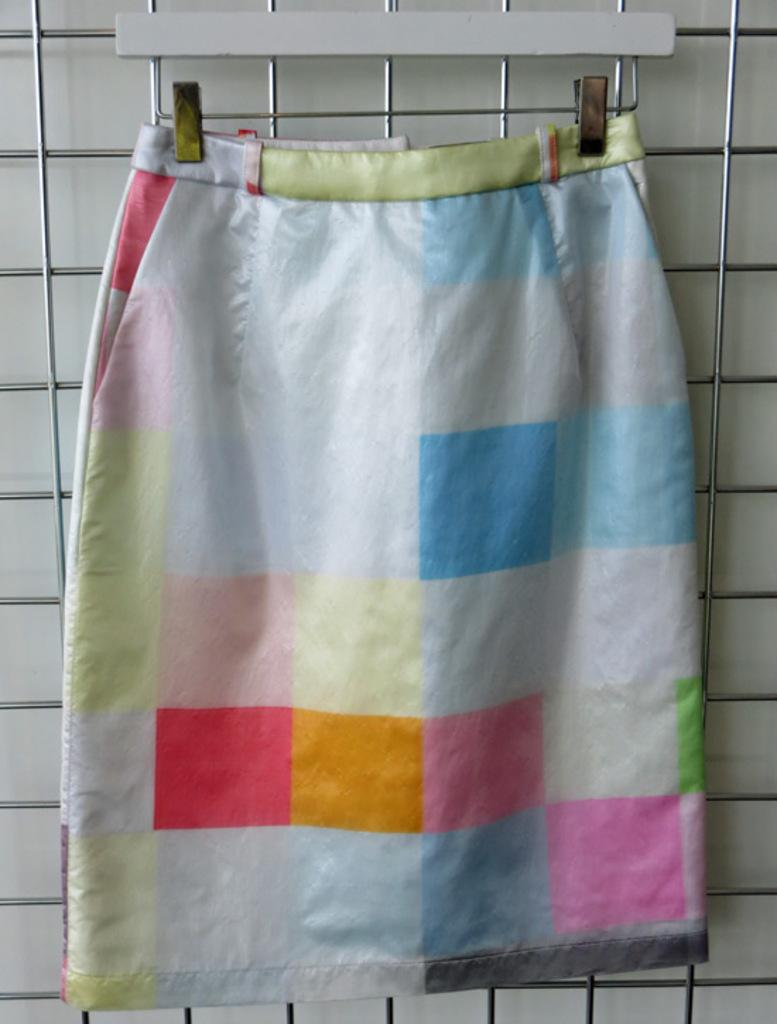What type of clothing item is in the image? There is a skirt in the image. Where is the skirt located? The skirt is on a grill. What type of fang can be seen in the image? There is no fang present in the image; it features a skirt on a grill. Can you tell me the account number of the person who owns the skirt in the image? There is no account number or personal information provided in the image, as it only shows a skirt on a grill. 